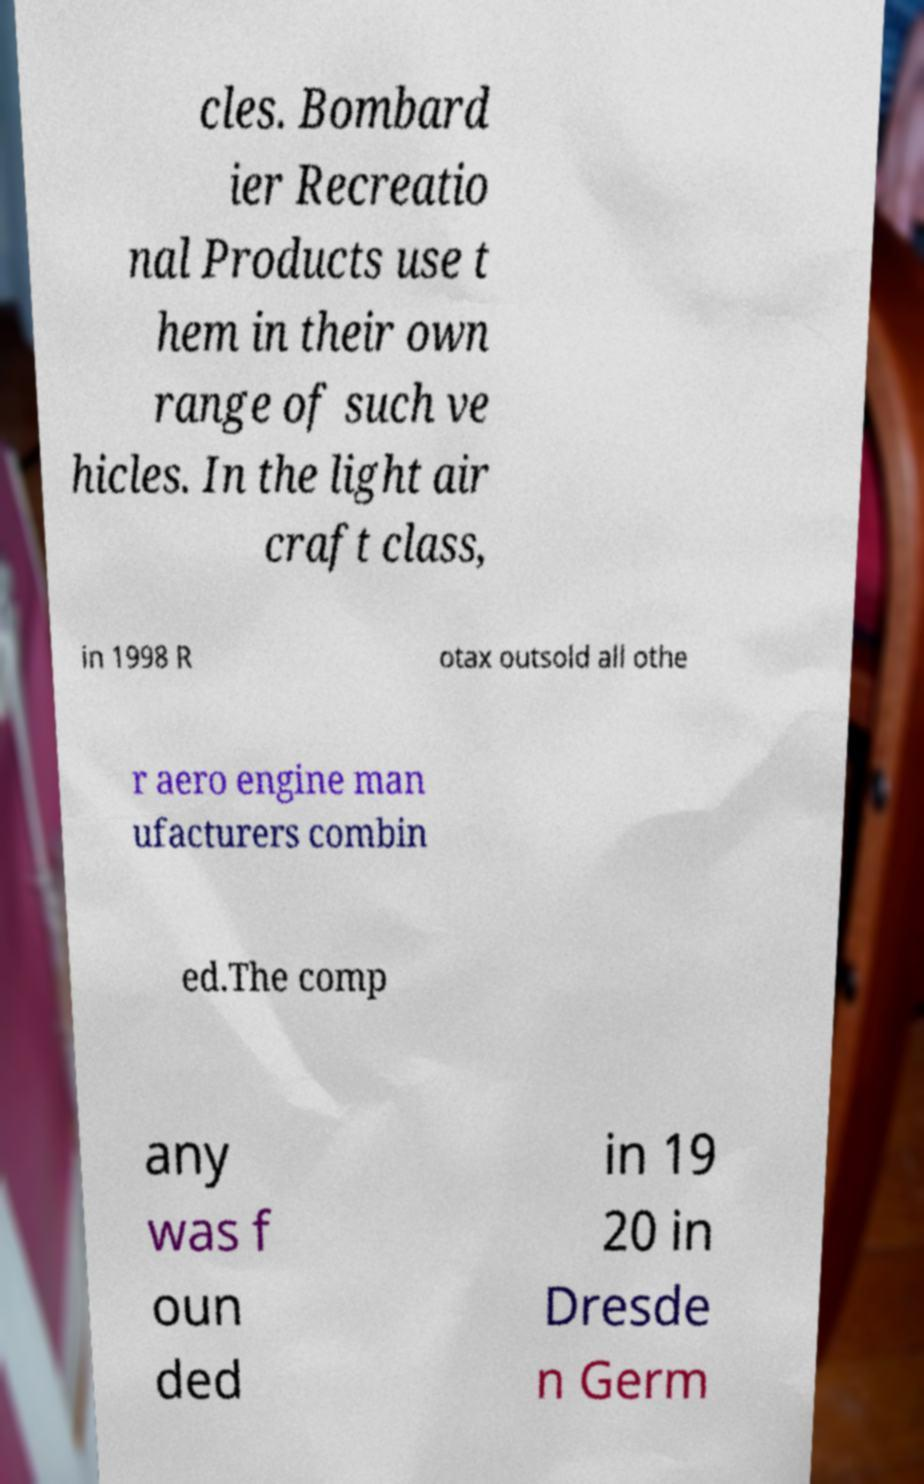Could you assist in decoding the text presented in this image and type it out clearly? cles. Bombard ier Recreatio nal Products use t hem in their own range of such ve hicles. In the light air craft class, in 1998 R otax outsold all othe r aero engine man ufacturers combin ed.The comp any was f oun ded in 19 20 in Dresde n Germ 